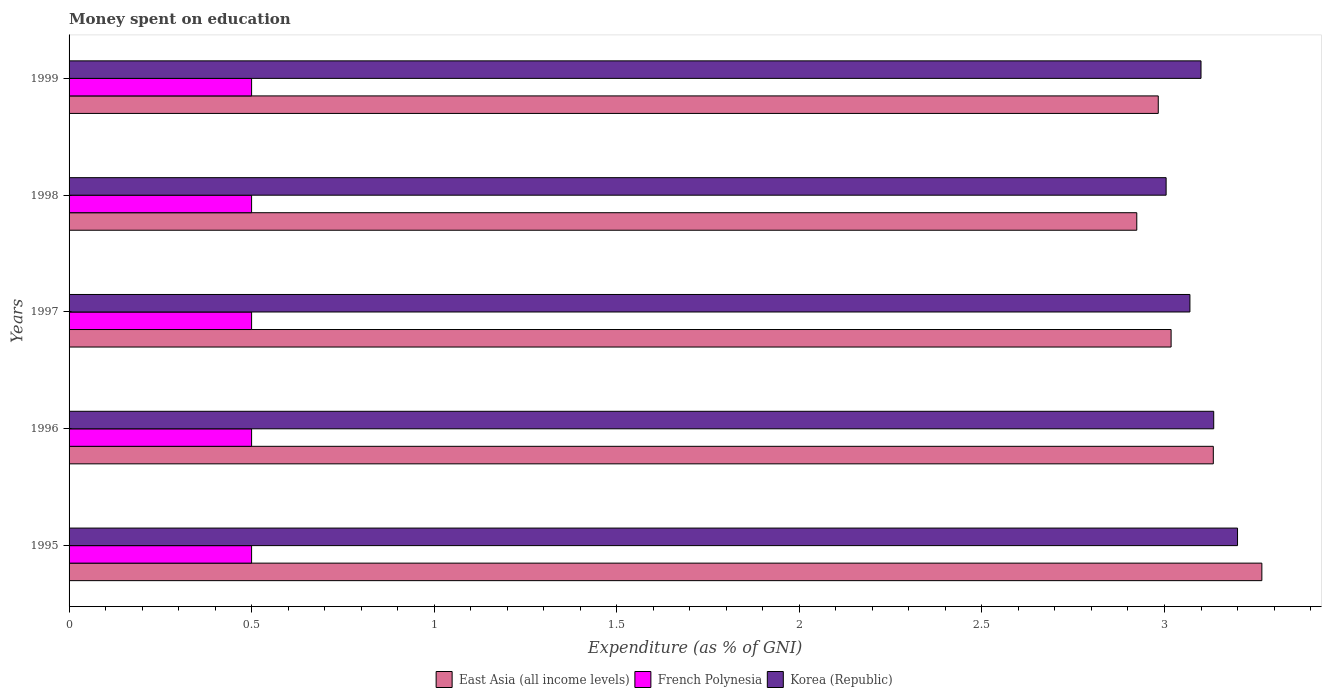How many groups of bars are there?
Keep it short and to the point. 5. What is the amount of money spent on education in East Asia (all income levels) in 1997?
Give a very brief answer. 3.02. Across all years, what is the minimum amount of money spent on education in East Asia (all income levels)?
Offer a very short reply. 2.92. In which year was the amount of money spent on education in French Polynesia maximum?
Offer a very short reply. 1995. What is the total amount of money spent on education in French Polynesia in the graph?
Ensure brevity in your answer.  2.5. What is the difference between the amount of money spent on education in East Asia (all income levels) in 1996 and that in 1998?
Give a very brief answer. 0.21. What is the difference between the amount of money spent on education in Korea (Republic) in 1997 and the amount of money spent on education in French Polynesia in 1998?
Your response must be concise. 2.57. What is the average amount of money spent on education in Korea (Republic) per year?
Provide a short and direct response. 3.1. In the year 1996, what is the difference between the amount of money spent on education in French Polynesia and amount of money spent on education in East Asia (all income levels)?
Your answer should be very brief. -2.63. In how many years, is the amount of money spent on education in Korea (Republic) greater than 1.8 %?
Keep it short and to the point. 5. What is the ratio of the amount of money spent on education in East Asia (all income levels) in 1997 to that in 1998?
Your answer should be compact. 1.03. Is the amount of money spent on education in Korea (Republic) in 1996 less than that in 1998?
Keep it short and to the point. No. What is the difference between the highest and the second highest amount of money spent on education in Korea (Republic)?
Give a very brief answer. 0.07. What is the difference between the highest and the lowest amount of money spent on education in Korea (Republic)?
Your answer should be compact. 0.2. In how many years, is the amount of money spent on education in French Polynesia greater than the average amount of money spent on education in French Polynesia taken over all years?
Give a very brief answer. 0. Is the sum of the amount of money spent on education in French Polynesia in 1995 and 1997 greater than the maximum amount of money spent on education in East Asia (all income levels) across all years?
Your response must be concise. No. What does the 1st bar from the top in 1998 represents?
Your answer should be very brief. Korea (Republic). What does the 2nd bar from the bottom in 1998 represents?
Give a very brief answer. French Polynesia. Is it the case that in every year, the sum of the amount of money spent on education in French Polynesia and amount of money spent on education in Korea (Republic) is greater than the amount of money spent on education in East Asia (all income levels)?
Make the answer very short. Yes. How many bars are there?
Keep it short and to the point. 15. How many years are there in the graph?
Give a very brief answer. 5. What is the difference between two consecutive major ticks on the X-axis?
Provide a short and direct response. 0.5. Are the values on the major ticks of X-axis written in scientific E-notation?
Make the answer very short. No. Does the graph contain any zero values?
Offer a very short reply. No. How many legend labels are there?
Give a very brief answer. 3. What is the title of the graph?
Make the answer very short. Money spent on education. What is the label or title of the X-axis?
Offer a terse response. Expenditure (as % of GNI). What is the label or title of the Y-axis?
Offer a very short reply. Years. What is the Expenditure (as % of GNI) of East Asia (all income levels) in 1995?
Offer a terse response. 3.27. What is the Expenditure (as % of GNI) of French Polynesia in 1995?
Provide a succinct answer. 0.5. What is the Expenditure (as % of GNI) of Korea (Republic) in 1995?
Your response must be concise. 3.2. What is the Expenditure (as % of GNI) of East Asia (all income levels) in 1996?
Provide a short and direct response. 3.13. What is the Expenditure (as % of GNI) in French Polynesia in 1996?
Make the answer very short. 0.5. What is the Expenditure (as % of GNI) of Korea (Republic) in 1996?
Offer a terse response. 3.13. What is the Expenditure (as % of GNI) of East Asia (all income levels) in 1997?
Provide a short and direct response. 3.02. What is the Expenditure (as % of GNI) of French Polynesia in 1997?
Offer a very short reply. 0.5. What is the Expenditure (as % of GNI) of Korea (Republic) in 1997?
Make the answer very short. 3.07. What is the Expenditure (as % of GNI) of East Asia (all income levels) in 1998?
Your answer should be very brief. 2.92. What is the Expenditure (as % of GNI) of French Polynesia in 1998?
Keep it short and to the point. 0.5. What is the Expenditure (as % of GNI) of Korea (Republic) in 1998?
Provide a short and direct response. 3. What is the Expenditure (as % of GNI) in East Asia (all income levels) in 1999?
Make the answer very short. 2.98. What is the Expenditure (as % of GNI) in French Polynesia in 1999?
Make the answer very short. 0.5. Across all years, what is the maximum Expenditure (as % of GNI) in East Asia (all income levels)?
Provide a short and direct response. 3.27. Across all years, what is the maximum Expenditure (as % of GNI) in French Polynesia?
Keep it short and to the point. 0.5. Across all years, what is the maximum Expenditure (as % of GNI) in Korea (Republic)?
Your answer should be very brief. 3.2. Across all years, what is the minimum Expenditure (as % of GNI) in East Asia (all income levels)?
Your response must be concise. 2.92. Across all years, what is the minimum Expenditure (as % of GNI) of French Polynesia?
Give a very brief answer. 0.5. Across all years, what is the minimum Expenditure (as % of GNI) in Korea (Republic)?
Your answer should be very brief. 3. What is the total Expenditure (as % of GNI) in East Asia (all income levels) in the graph?
Make the answer very short. 15.33. What is the total Expenditure (as % of GNI) of French Polynesia in the graph?
Provide a succinct answer. 2.5. What is the total Expenditure (as % of GNI) in Korea (Republic) in the graph?
Offer a very short reply. 15.51. What is the difference between the Expenditure (as % of GNI) in East Asia (all income levels) in 1995 and that in 1996?
Provide a short and direct response. 0.13. What is the difference between the Expenditure (as % of GNI) in French Polynesia in 1995 and that in 1996?
Your response must be concise. 0. What is the difference between the Expenditure (as % of GNI) in Korea (Republic) in 1995 and that in 1996?
Offer a very short reply. 0.07. What is the difference between the Expenditure (as % of GNI) of East Asia (all income levels) in 1995 and that in 1997?
Give a very brief answer. 0.25. What is the difference between the Expenditure (as % of GNI) of Korea (Republic) in 1995 and that in 1997?
Your response must be concise. 0.13. What is the difference between the Expenditure (as % of GNI) of East Asia (all income levels) in 1995 and that in 1998?
Offer a very short reply. 0.34. What is the difference between the Expenditure (as % of GNI) in Korea (Republic) in 1995 and that in 1998?
Provide a short and direct response. 0.2. What is the difference between the Expenditure (as % of GNI) in East Asia (all income levels) in 1995 and that in 1999?
Give a very brief answer. 0.28. What is the difference between the Expenditure (as % of GNI) in French Polynesia in 1995 and that in 1999?
Make the answer very short. 0. What is the difference between the Expenditure (as % of GNI) in Korea (Republic) in 1995 and that in 1999?
Offer a very short reply. 0.1. What is the difference between the Expenditure (as % of GNI) of East Asia (all income levels) in 1996 and that in 1997?
Provide a short and direct response. 0.12. What is the difference between the Expenditure (as % of GNI) in French Polynesia in 1996 and that in 1997?
Provide a short and direct response. 0. What is the difference between the Expenditure (as % of GNI) of Korea (Republic) in 1996 and that in 1997?
Make the answer very short. 0.07. What is the difference between the Expenditure (as % of GNI) in East Asia (all income levels) in 1996 and that in 1998?
Give a very brief answer. 0.21. What is the difference between the Expenditure (as % of GNI) of French Polynesia in 1996 and that in 1998?
Your answer should be compact. 0. What is the difference between the Expenditure (as % of GNI) of Korea (Republic) in 1996 and that in 1998?
Make the answer very short. 0.13. What is the difference between the Expenditure (as % of GNI) of East Asia (all income levels) in 1996 and that in 1999?
Offer a terse response. 0.15. What is the difference between the Expenditure (as % of GNI) in Korea (Republic) in 1996 and that in 1999?
Keep it short and to the point. 0.03. What is the difference between the Expenditure (as % of GNI) of East Asia (all income levels) in 1997 and that in 1998?
Your answer should be very brief. 0.09. What is the difference between the Expenditure (as % of GNI) of Korea (Republic) in 1997 and that in 1998?
Make the answer very short. 0.07. What is the difference between the Expenditure (as % of GNI) of East Asia (all income levels) in 1997 and that in 1999?
Ensure brevity in your answer.  0.04. What is the difference between the Expenditure (as % of GNI) of Korea (Republic) in 1997 and that in 1999?
Ensure brevity in your answer.  -0.03. What is the difference between the Expenditure (as % of GNI) in East Asia (all income levels) in 1998 and that in 1999?
Your answer should be very brief. -0.06. What is the difference between the Expenditure (as % of GNI) of Korea (Republic) in 1998 and that in 1999?
Give a very brief answer. -0.1. What is the difference between the Expenditure (as % of GNI) of East Asia (all income levels) in 1995 and the Expenditure (as % of GNI) of French Polynesia in 1996?
Your response must be concise. 2.77. What is the difference between the Expenditure (as % of GNI) in East Asia (all income levels) in 1995 and the Expenditure (as % of GNI) in Korea (Republic) in 1996?
Offer a very short reply. 0.13. What is the difference between the Expenditure (as % of GNI) in French Polynesia in 1995 and the Expenditure (as % of GNI) in Korea (Republic) in 1996?
Your answer should be compact. -2.63. What is the difference between the Expenditure (as % of GNI) of East Asia (all income levels) in 1995 and the Expenditure (as % of GNI) of French Polynesia in 1997?
Offer a very short reply. 2.77. What is the difference between the Expenditure (as % of GNI) of East Asia (all income levels) in 1995 and the Expenditure (as % of GNI) of Korea (Republic) in 1997?
Make the answer very short. 0.2. What is the difference between the Expenditure (as % of GNI) in French Polynesia in 1995 and the Expenditure (as % of GNI) in Korea (Republic) in 1997?
Provide a succinct answer. -2.57. What is the difference between the Expenditure (as % of GNI) in East Asia (all income levels) in 1995 and the Expenditure (as % of GNI) in French Polynesia in 1998?
Your answer should be very brief. 2.77. What is the difference between the Expenditure (as % of GNI) in East Asia (all income levels) in 1995 and the Expenditure (as % of GNI) in Korea (Republic) in 1998?
Your answer should be compact. 0.26. What is the difference between the Expenditure (as % of GNI) in French Polynesia in 1995 and the Expenditure (as % of GNI) in Korea (Republic) in 1998?
Give a very brief answer. -2.5. What is the difference between the Expenditure (as % of GNI) of East Asia (all income levels) in 1995 and the Expenditure (as % of GNI) of French Polynesia in 1999?
Offer a terse response. 2.77. What is the difference between the Expenditure (as % of GNI) in East Asia (all income levels) in 1995 and the Expenditure (as % of GNI) in Korea (Republic) in 1999?
Your response must be concise. 0.17. What is the difference between the Expenditure (as % of GNI) of French Polynesia in 1995 and the Expenditure (as % of GNI) of Korea (Republic) in 1999?
Provide a succinct answer. -2.6. What is the difference between the Expenditure (as % of GNI) in East Asia (all income levels) in 1996 and the Expenditure (as % of GNI) in French Polynesia in 1997?
Your response must be concise. 2.63. What is the difference between the Expenditure (as % of GNI) in East Asia (all income levels) in 1996 and the Expenditure (as % of GNI) in Korea (Republic) in 1997?
Your answer should be compact. 0.06. What is the difference between the Expenditure (as % of GNI) of French Polynesia in 1996 and the Expenditure (as % of GNI) of Korea (Republic) in 1997?
Keep it short and to the point. -2.57. What is the difference between the Expenditure (as % of GNI) in East Asia (all income levels) in 1996 and the Expenditure (as % of GNI) in French Polynesia in 1998?
Make the answer very short. 2.63. What is the difference between the Expenditure (as % of GNI) of East Asia (all income levels) in 1996 and the Expenditure (as % of GNI) of Korea (Republic) in 1998?
Make the answer very short. 0.13. What is the difference between the Expenditure (as % of GNI) in French Polynesia in 1996 and the Expenditure (as % of GNI) in Korea (Republic) in 1998?
Your response must be concise. -2.5. What is the difference between the Expenditure (as % of GNI) of East Asia (all income levels) in 1996 and the Expenditure (as % of GNI) of French Polynesia in 1999?
Make the answer very short. 2.63. What is the difference between the Expenditure (as % of GNI) in East Asia (all income levels) in 1996 and the Expenditure (as % of GNI) in Korea (Republic) in 1999?
Provide a short and direct response. 0.03. What is the difference between the Expenditure (as % of GNI) of French Polynesia in 1996 and the Expenditure (as % of GNI) of Korea (Republic) in 1999?
Your response must be concise. -2.6. What is the difference between the Expenditure (as % of GNI) in East Asia (all income levels) in 1997 and the Expenditure (as % of GNI) in French Polynesia in 1998?
Your response must be concise. 2.52. What is the difference between the Expenditure (as % of GNI) of East Asia (all income levels) in 1997 and the Expenditure (as % of GNI) of Korea (Republic) in 1998?
Offer a very short reply. 0.01. What is the difference between the Expenditure (as % of GNI) of French Polynesia in 1997 and the Expenditure (as % of GNI) of Korea (Republic) in 1998?
Your answer should be compact. -2.5. What is the difference between the Expenditure (as % of GNI) in East Asia (all income levels) in 1997 and the Expenditure (as % of GNI) in French Polynesia in 1999?
Your answer should be very brief. 2.52. What is the difference between the Expenditure (as % of GNI) in East Asia (all income levels) in 1997 and the Expenditure (as % of GNI) in Korea (Republic) in 1999?
Make the answer very short. -0.08. What is the difference between the Expenditure (as % of GNI) of French Polynesia in 1997 and the Expenditure (as % of GNI) of Korea (Republic) in 1999?
Make the answer very short. -2.6. What is the difference between the Expenditure (as % of GNI) in East Asia (all income levels) in 1998 and the Expenditure (as % of GNI) in French Polynesia in 1999?
Make the answer very short. 2.42. What is the difference between the Expenditure (as % of GNI) of East Asia (all income levels) in 1998 and the Expenditure (as % of GNI) of Korea (Republic) in 1999?
Your response must be concise. -0.18. What is the difference between the Expenditure (as % of GNI) in French Polynesia in 1998 and the Expenditure (as % of GNI) in Korea (Republic) in 1999?
Your response must be concise. -2.6. What is the average Expenditure (as % of GNI) in East Asia (all income levels) per year?
Provide a succinct answer. 3.07. What is the average Expenditure (as % of GNI) of French Polynesia per year?
Your answer should be very brief. 0.5. What is the average Expenditure (as % of GNI) of Korea (Republic) per year?
Ensure brevity in your answer.  3.1. In the year 1995, what is the difference between the Expenditure (as % of GNI) in East Asia (all income levels) and Expenditure (as % of GNI) in French Polynesia?
Ensure brevity in your answer.  2.77. In the year 1995, what is the difference between the Expenditure (as % of GNI) of East Asia (all income levels) and Expenditure (as % of GNI) of Korea (Republic)?
Your response must be concise. 0.07. In the year 1995, what is the difference between the Expenditure (as % of GNI) in French Polynesia and Expenditure (as % of GNI) in Korea (Republic)?
Offer a terse response. -2.7. In the year 1996, what is the difference between the Expenditure (as % of GNI) of East Asia (all income levels) and Expenditure (as % of GNI) of French Polynesia?
Keep it short and to the point. 2.63. In the year 1996, what is the difference between the Expenditure (as % of GNI) in East Asia (all income levels) and Expenditure (as % of GNI) in Korea (Republic)?
Give a very brief answer. -0. In the year 1996, what is the difference between the Expenditure (as % of GNI) of French Polynesia and Expenditure (as % of GNI) of Korea (Republic)?
Give a very brief answer. -2.63. In the year 1997, what is the difference between the Expenditure (as % of GNI) in East Asia (all income levels) and Expenditure (as % of GNI) in French Polynesia?
Keep it short and to the point. 2.52. In the year 1997, what is the difference between the Expenditure (as % of GNI) of East Asia (all income levels) and Expenditure (as % of GNI) of Korea (Republic)?
Give a very brief answer. -0.05. In the year 1997, what is the difference between the Expenditure (as % of GNI) of French Polynesia and Expenditure (as % of GNI) of Korea (Republic)?
Your answer should be compact. -2.57. In the year 1998, what is the difference between the Expenditure (as % of GNI) in East Asia (all income levels) and Expenditure (as % of GNI) in French Polynesia?
Provide a succinct answer. 2.42. In the year 1998, what is the difference between the Expenditure (as % of GNI) in East Asia (all income levels) and Expenditure (as % of GNI) in Korea (Republic)?
Offer a terse response. -0.08. In the year 1998, what is the difference between the Expenditure (as % of GNI) in French Polynesia and Expenditure (as % of GNI) in Korea (Republic)?
Make the answer very short. -2.5. In the year 1999, what is the difference between the Expenditure (as % of GNI) of East Asia (all income levels) and Expenditure (as % of GNI) of French Polynesia?
Provide a short and direct response. 2.48. In the year 1999, what is the difference between the Expenditure (as % of GNI) in East Asia (all income levels) and Expenditure (as % of GNI) in Korea (Republic)?
Offer a terse response. -0.12. In the year 1999, what is the difference between the Expenditure (as % of GNI) in French Polynesia and Expenditure (as % of GNI) in Korea (Republic)?
Your response must be concise. -2.6. What is the ratio of the Expenditure (as % of GNI) of East Asia (all income levels) in 1995 to that in 1996?
Offer a very short reply. 1.04. What is the ratio of the Expenditure (as % of GNI) in Korea (Republic) in 1995 to that in 1996?
Provide a short and direct response. 1.02. What is the ratio of the Expenditure (as % of GNI) of East Asia (all income levels) in 1995 to that in 1997?
Offer a very short reply. 1.08. What is the ratio of the Expenditure (as % of GNI) in Korea (Republic) in 1995 to that in 1997?
Ensure brevity in your answer.  1.04. What is the ratio of the Expenditure (as % of GNI) of East Asia (all income levels) in 1995 to that in 1998?
Provide a short and direct response. 1.12. What is the ratio of the Expenditure (as % of GNI) of Korea (Republic) in 1995 to that in 1998?
Ensure brevity in your answer.  1.07. What is the ratio of the Expenditure (as % of GNI) of East Asia (all income levels) in 1995 to that in 1999?
Your answer should be compact. 1.1. What is the ratio of the Expenditure (as % of GNI) in Korea (Republic) in 1995 to that in 1999?
Your answer should be compact. 1.03. What is the ratio of the Expenditure (as % of GNI) in East Asia (all income levels) in 1996 to that in 1997?
Ensure brevity in your answer.  1.04. What is the ratio of the Expenditure (as % of GNI) in French Polynesia in 1996 to that in 1997?
Ensure brevity in your answer.  1. What is the ratio of the Expenditure (as % of GNI) of Korea (Republic) in 1996 to that in 1997?
Your response must be concise. 1.02. What is the ratio of the Expenditure (as % of GNI) of East Asia (all income levels) in 1996 to that in 1998?
Keep it short and to the point. 1.07. What is the ratio of the Expenditure (as % of GNI) of French Polynesia in 1996 to that in 1998?
Provide a short and direct response. 1. What is the ratio of the Expenditure (as % of GNI) of Korea (Republic) in 1996 to that in 1998?
Your answer should be very brief. 1.04. What is the ratio of the Expenditure (as % of GNI) of East Asia (all income levels) in 1996 to that in 1999?
Your answer should be compact. 1.05. What is the ratio of the Expenditure (as % of GNI) in French Polynesia in 1996 to that in 1999?
Keep it short and to the point. 1. What is the ratio of the Expenditure (as % of GNI) of Korea (Republic) in 1996 to that in 1999?
Offer a very short reply. 1.01. What is the ratio of the Expenditure (as % of GNI) in East Asia (all income levels) in 1997 to that in 1998?
Provide a succinct answer. 1.03. What is the ratio of the Expenditure (as % of GNI) in Korea (Republic) in 1997 to that in 1998?
Your answer should be very brief. 1.02. What is the ratio of the Expenditure (as % of GNI) in East Asia (all income levels) in 1997 to that in 1999?
Provide a short and direct response. 1.01. What is the ratio of the Expenditure (as % of GNI) in Korea (Republic) in 1997 to that in 1999?
Make the answer very short. 0.99. What is the ratio of the Expenditure (as % of GNI) of East Asia (all income levels) in 1998 to that in 1999?
Give a very brief answer. 0.98. What is the ratio of the Expenditure (as % of GNI) of French Polynesia in 1998 to that in 1999?
Provide a succinct answer. 1. What is the ratio of the Expenditure (as % of GNI) in Korea (Republic) in 1998 to that in 1999?
Your answer should be compact. 0.97. What is the difference between the highest and the second highest Expenditure (as % of GNI) in East Asia (all income levels)?
Give a very brief answer. 0.13. What is the difference between the highest and the second highest Expenditure (as % of GNI) of French Polynesia?
Your answer should be very brief. 0. What is the difference between the highest and the second highest Expenditure (as % of GNI) of Korea (Republic)?
Provide a succinct answer. 0.07. What is the difference between the highest and the lowest Expenditure (as % of GNI) in East Asia (all income levels)?
Provide a short and direct response. 0.34. What is the difference between the highest and the lowest Expenditure (as % of GNI) of French Polynesia?
Offer a terse response. 0. What is the difference between the highest and the lowest Expenditure (as % of GNI) in Korea (Republic)?
Make the answer very short. 0.2. 